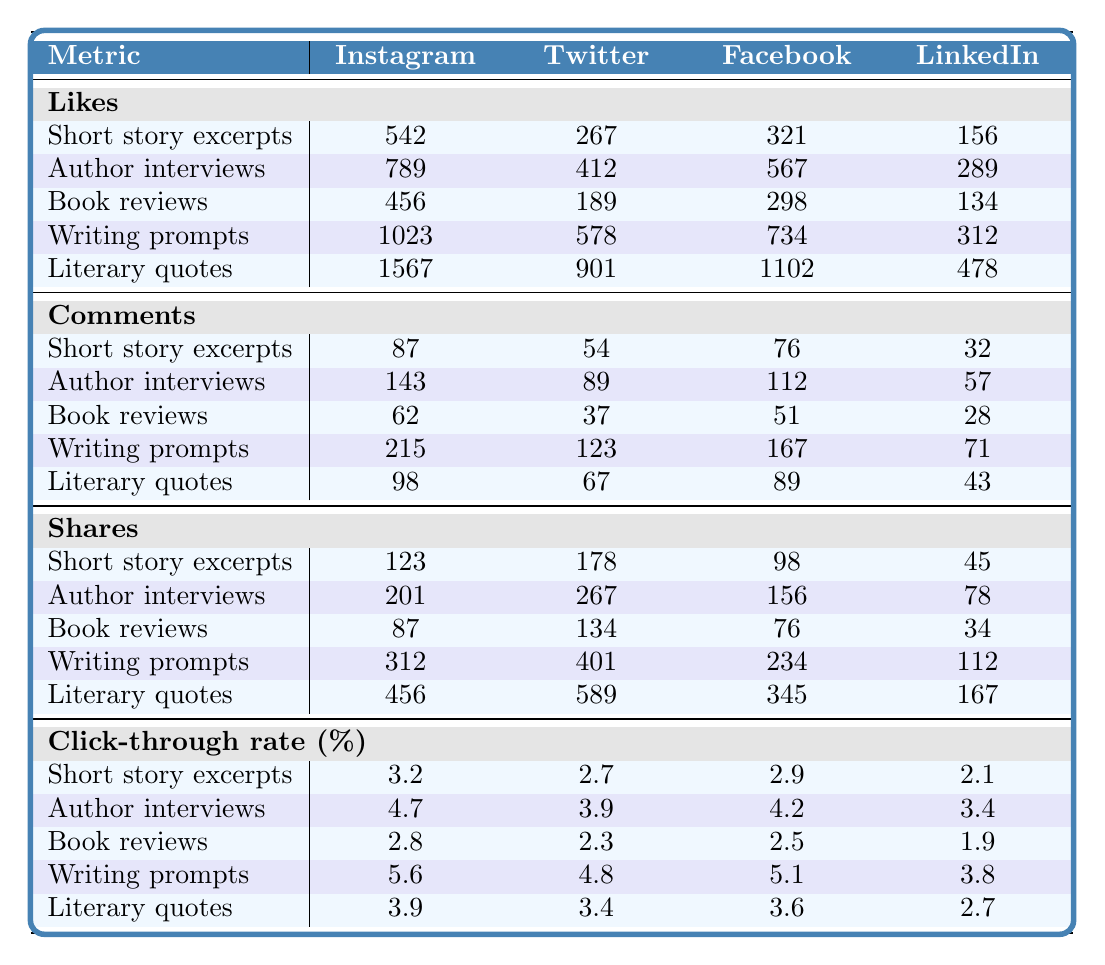What is the number of Likes for Author interviews on Facebook? The table shows that for Author interviews, Facebook has 567 Likes listed.
Answer: 567 Which content type received the most Likes on Instagram? Reviewing the Likes row for Instagram, Writing prompts received the most Likes with a total of 1023.
Answer: Writing prompts What is the difference in Likes between Literary quotes on Twitter and Short story excerpts on Facebook? Literary quotes on Twitter have 901 Likes, while Short story excerpts on Facebook have 321 Likes. The difference is 901 - 321 = 580.
Answer: 580 What is the average Click-through rate for Book reviews across all platforms? The Click-through rates for Book reviews are 2.8 (Instagram), 2.3 (Twitter), 2.5 (Facebook), and 1.9 (LinkedIn). Summing these gives 2.8 + 2.3 + 2.5 + 1.9 = 9.5, and dividing by 4 gives an average of 9.5 / 4 = 2.375.
Answer: 2.375 Which metric had the highest overall engagement (Likes, Comments, Shares) for Writing prompts on Facebook? Writing prompts had Likes of 734, Comments of 167, and Shares of 234. Summing these five metrics gives 734 + 167 + 234 = 1135.
Answer: 1135 Is the Click-through rate for Literary quotes on Instagram higher than 4%? The Click-through rate for Literary quotes on Instagram is 3.9%, which is less than 4%.
Answer: No What is the total number of Shares for Short story excerpts across all platforms? Summing Shares for Short story excerpts: Instagram (123) + Twitter (178) + Facebook (98) + LinkedIn (45) gives 123 + 178 + 98 + 45 = 444.
Answer: 444 Which platform has the highest Engagement rate for Author interviews? The Engagement rate isn't provided in the table but requires calculating other metrics. Without that data, we cannot determine which platform has the highest rate for Author interviews.
Answer: Not available What is the percentage difference in Click-through rates between Author interviews on Instagram and LinkedIn? The Click-through rate for Author interviews is 4.7% on Instagram and 3.4% on LinkedIn. The percentage difference is calculated as (4.7 - 3.4) / 4.7 x 100% = 27.66%.
Answer: 27.66% 